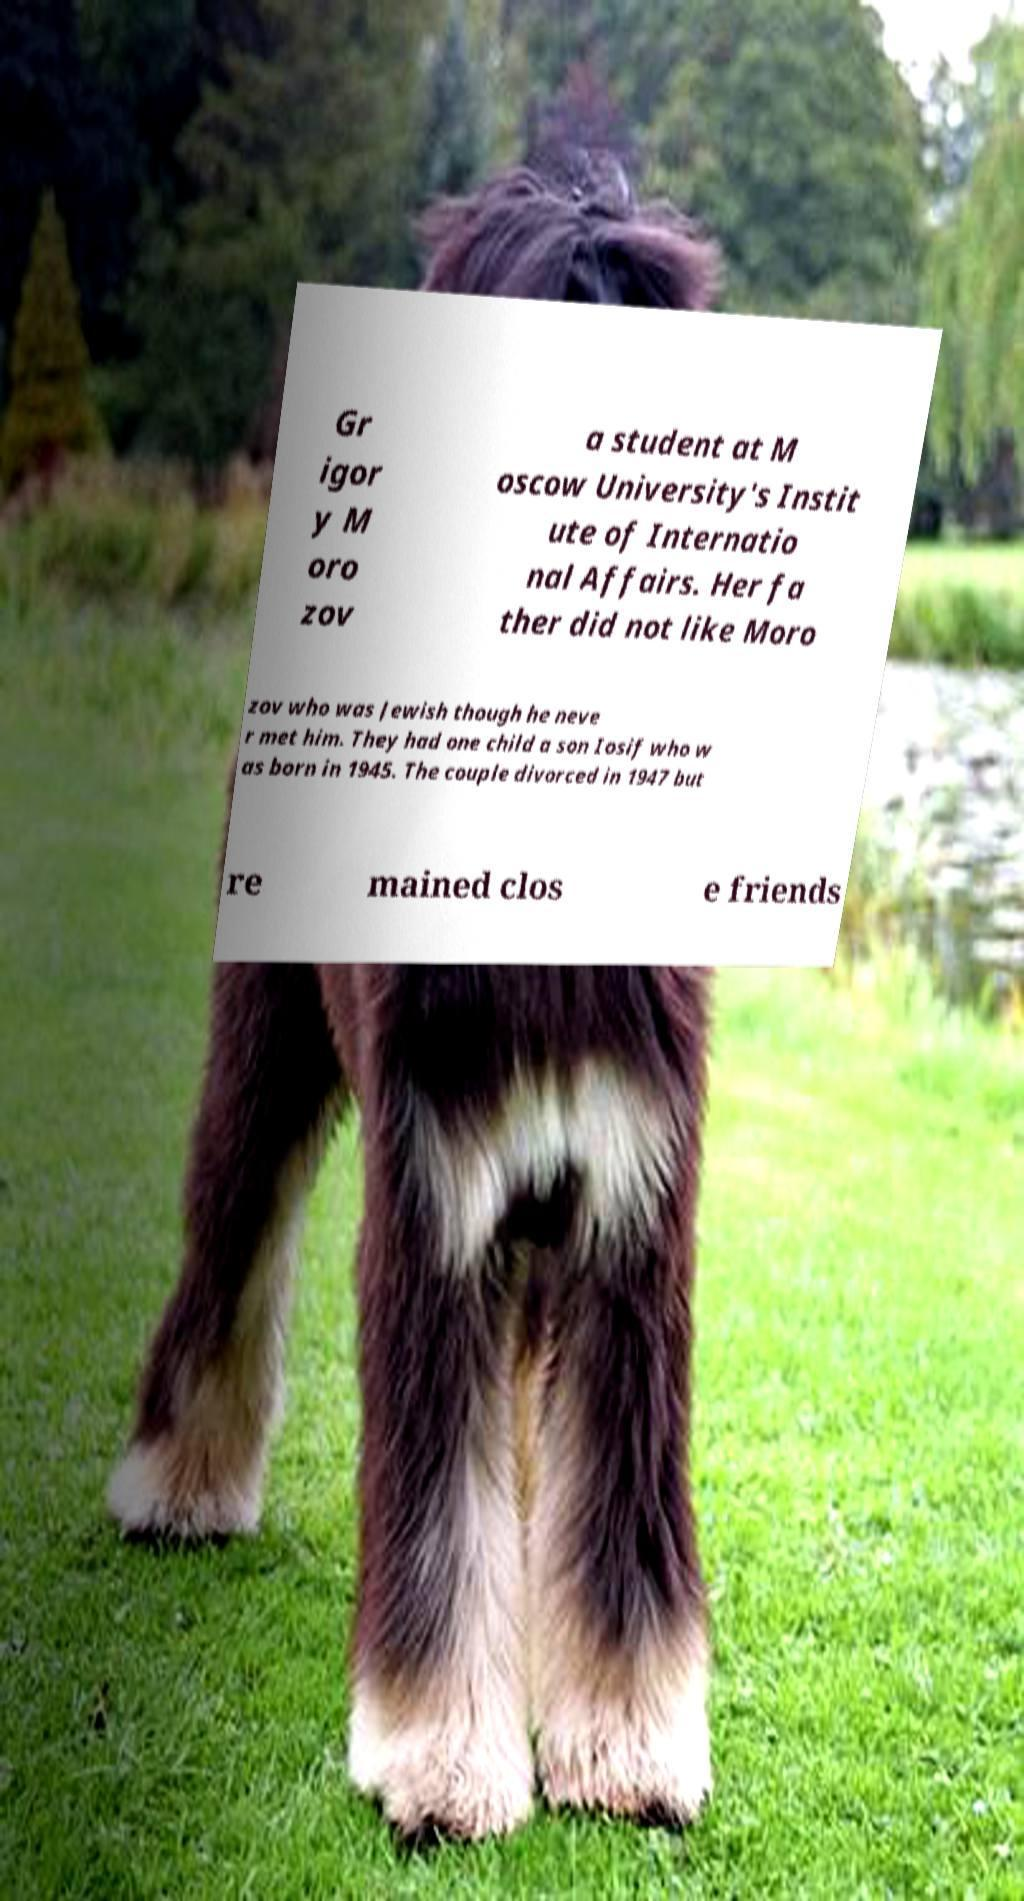I need the written content from this picture converted into text. Can you do that? Gr igor y M oro zov a student at M oscow University's Instit ute of Internatio nal Affairs. Her fa ther did not like Moro zov who was Jewish though he neve r met him. They had one child a son Iosif who w as born in 1945. The couple divorced in 1947 but re mained clos e friends 